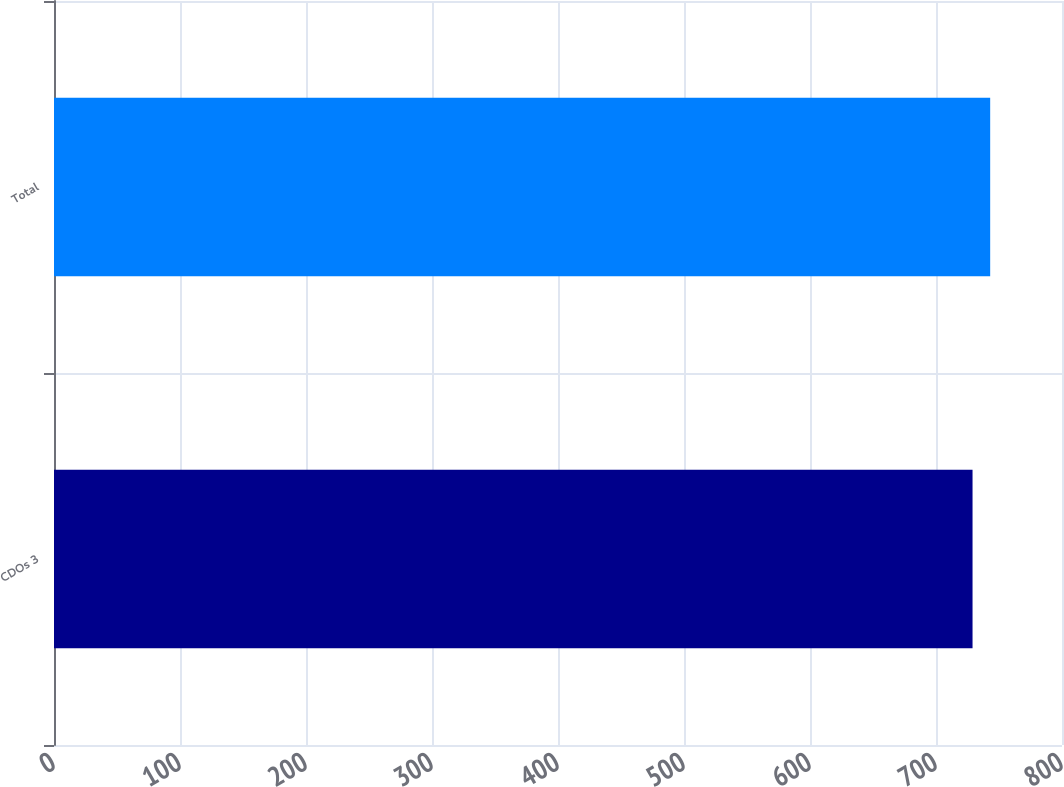<chart> <loc_0><loc_0><loc_500><loc_500><bar_chart><fcel>CDOs 3<fcel>Total<nl><fcel>729<fcel>743<nl></chart> 